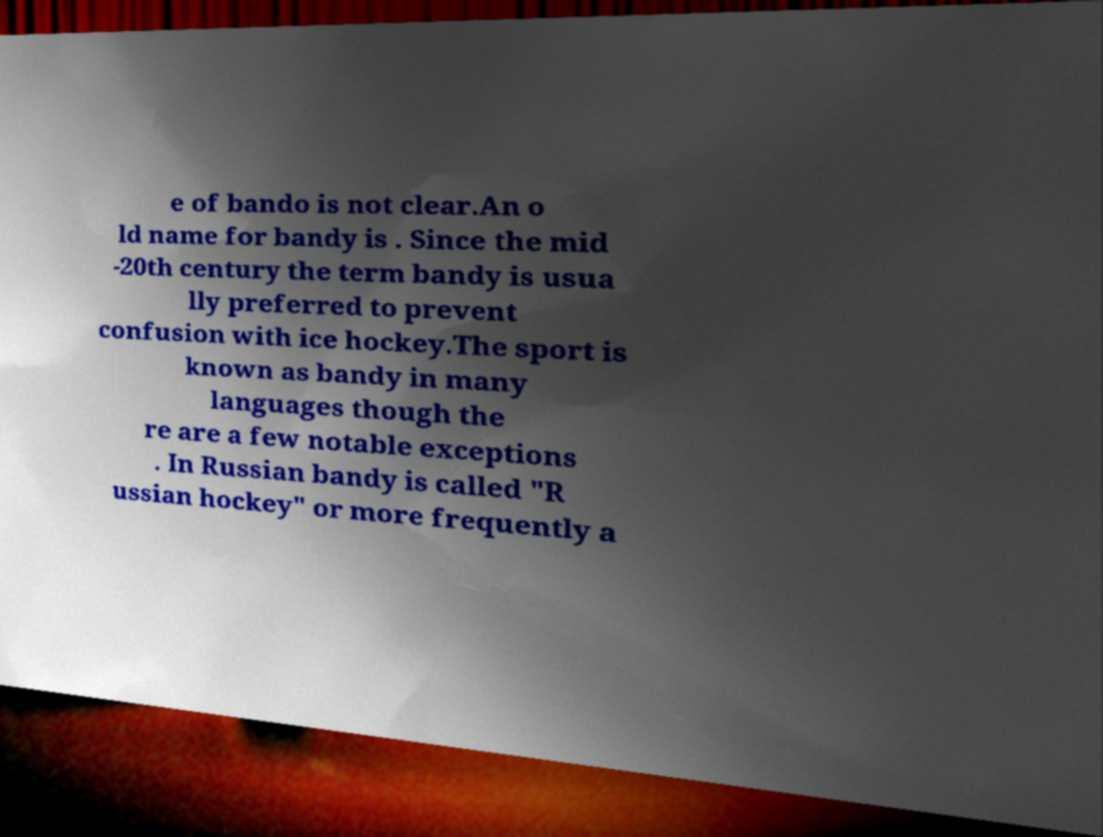There's text embedded in this image that I need extracted. Can you transcribe it verbatim? e of bando is not clear.An o ld name for bandy is . Since the mid -20th century the term bandy is usua lly preferred to prevent confusion with ice hockey.The sport is known as bandy in many languages though the re are a few notable exceptions . In Russian bandy is called "R ussian hockey" or more frequently a 